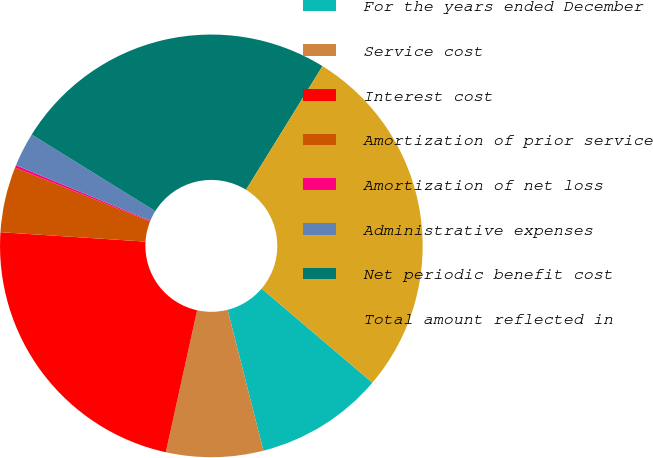<chart> <loc_0><loc_0><loc_500><loc_500><pie_chart><fcel>For the years ended December<fcel>Service cost<fcel>Interest cost<fcel>Amortization of prior service<fcel>Amortization of net loss<fcel>Administrative expenses<fcel>Net periodic benefit cost<fcel>Total amount reflected in<nl><fcel>9.83%<fcel>7.42%<fcel>22.58%<fcel>5.01%<fcel>0.19%<fcel>2.6%<fcel>24.99%<fcel>27.4%<nl></chart> 